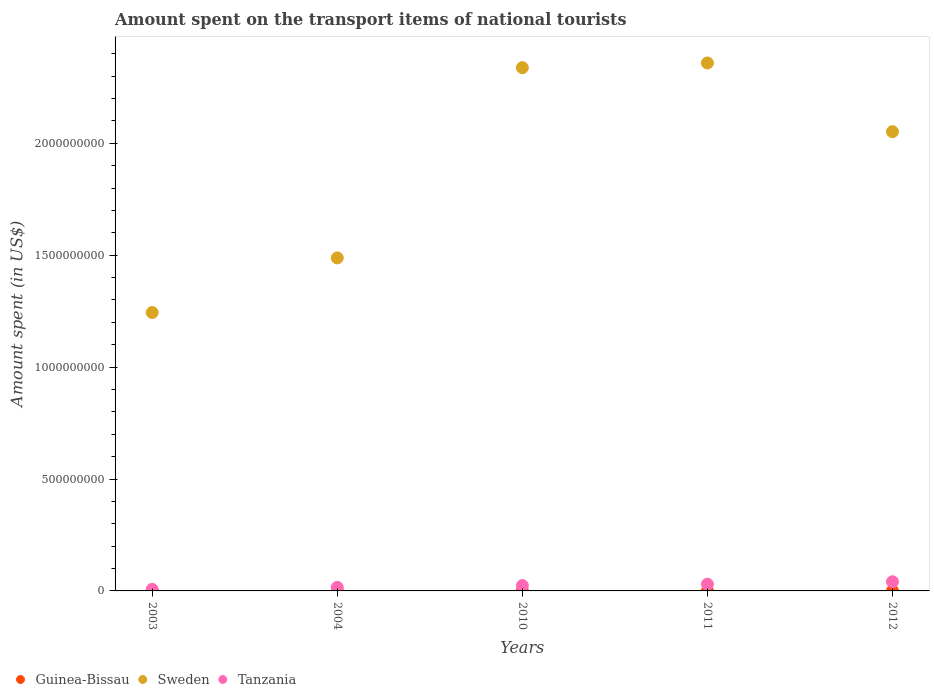Is the number of dotlines equal to the number of legend labels?
Offer a terse response. Yes. What is the amount spent on the transport items of national tourists in Sweden in 2010?
Offer a terse response. 2.34e+09. Across all years, what is the maximum amount spent on the transport items of national tourists in Tanzania?
Your response must be concise. 4.10e+07. In which year was the amount spent on the transport items of national tourists in Sweden maximum?
Offer a very short reply. 2011. What is the total amount spent on the transport items of national tourists in Tanzania in the graph?
Ensure brevity in your answer.  1.18e+08. What is the difference between the amount spent on the transport items of national tourists in Sweden in 2003 and that in 2011?
Make the answer very short. -1.12e+09. What is the difference between the amount spent on the transport items of national tourists in Sweden in 2003 and the amount spent on the transport items of national tourists in Tanzania in 2012?
Ensure brevity in your answer.  1.20e+09. What is the average amount spent on the transport items of national tourists in Sweden per year?
Ensure brevity in your answer.  1.90e+09. In the year 2004, what is the difference between the amount spent on the transport items of national tourists in Tanzania and amount spent on the transport items of national tourists in Sweden?
Provide a short and direct response. -1.47e+09. Is the difference between the amount spent on the transport items of national tourists in Tanzania in 2010 and 2011 greater than the difference between the amount spent on the transport items of national tourists in Sweden in 2010 and 2011?
Make the answer very short. Yes. What is the difference between the highest and the second highest amount spent on the transport items of national tourists in Sweden?
Provide a succinct answer. 2.10e+07. What is the difference between the highest and the lowest amount spent on the transport items of national tourists in Tanzania?
Ensure brevity in your answer.  3.40e+07. In how many years, is the amount spent on the transport items of national tourists in Guinea-Bissau greater than the average amount spent on the transport items of national tourists in Guinea-Bissau taken over all years?
Your answer should be compact. 2. Is the sum of the amount spent on the transport items of national tourists in Tanzania in 2004 and 2010 greater than the maximum amount spent on the transport items of national tourists in Sweden across all years?
Provide a short and direct response. No. Does the amount spent on the transport items of national tourists in Tanzania monotonically increase over the years?
Give a very brief answer. Yes. Is the amount spent on the transport items of national tourists in Tanzania strictly less than the amount spent on the transport items of national tourists in Guinea-Bissau over the years?
Make the answer very short. No. How many years are there in the graph?
Your response must be concise. 5. What is the difference between two consecutive major ticks on the Y-axis?
Give a very brief answer. 5.00e+08. Does the graph contain any zero values?
Offer a very short reply. No. What is the title of the graph?
Your answer should be very brief. Amount spent on the transport items of national tourists. What is the label or title of the Y-axis?
Make the answer very short. Amount spent (in US$). What is the Amount spent (in US$) of Sweden in 2003?
Give a very brief answer. 1.24e+09. What is the Amount spent (in US$) of Guinea-Bissau in 2004?
Your response must be concise. 1.20e+06. What is the Amount spent (in US$) of Sweden in 2004?
Provide a succinct answer. 1.49e+09. What is the Amount spent (in US$) in Tanzania in 2004?
Offer a terse response. 1.60e+07. What is the Amount spent (in US$) of Guinea-Bissau in 2010?
Offer a terse response. 3.00e+05. What is the Amount spent (in US$) of Sweden in 2010?
Provide a short and direct response. 2.34e+09. What is the Amount spent (in US$) in Tanzania in 2010?
Your answer should be compact. 2.40e+07. What is the Amount spent (in US$) of Guinea-Bissau in 2011?
Your answer should be compact. 4.00e+05. What is the Amount spent (in US$) of Sweden in 2011?
Your answer should be very brief. 2.36e+09. What is the Amount spent (in US$) of Tanzania in 2011?
Give a very brief answer. 3.00e+07. What is the Amount spent (in US$) in Guinea-Bissau in 2012?
Provide a succinct answer. 2.00e+05. What is the Amount spent (in US$) in Sweden in 2012?
Keep it short and to the point. 2.05e+09. What is the Amount spent (in US$) of Tanzania in 2012?
Your response must be concise. 4.10e+07. Across all years, what is the maximum Amount spent (in US$) in Guinea-Bissau?
Keep it short and to the point. 1.20e+06. Across all years, what is the maximum Amount spent (in US$) in Sweden?
Offer a very short reply. 2.36e+09. Across all years, what is the maximum Amount spent (in US$) in Tanzania?
Your response must be concise. 4.10e+07. Across all years, what is the minimum Amount spent (in US$) of Sweden?
Offer a terse response. 1.24e+09. What is the total Amount spent (in US$) in Guinea-Bissau in the graph?
Your answer should be very brief. 2.70e+06. What is the total Amount spent (in US$) in Sweden in the graph?
Ensure brevity in your answer.  9.48e+09. What is the total Amount spent (in US$) in Tanzania in the graph?
Your answer should be compact. 1.18e+08. What is the difference between the Amount spent (in US$) of Guinea-Bissau in 2003 and that in 2004?
Provide a succinct answer. -6.00e+05. What is the difference between the Amount spent (in US$) of Sweden in 2003 and that in 2004?
Ensure brevity in your answer.  -2.44e+08. What is the difference between the Amount spent (in US$) of Tanzania in 2003 and that in 2004?
Your answer should be compact. -9.00e+06. What is the difference between the Amount spent (in US$) of Guinea-Bissau in 2003 and that in 2010?
Keep it short and to the point. 3.00e+05. What is the difference between the Amount spent (in US$) of Sweden in 2003 and that in 2010?
Ensure brevity in your answer.  -1.09e+09. What is the difference between the Amount spent (in US$) in Tanzania in 2003 and that in 2010?
Provide a succinct answer. -1.70e+07. What is the difference between the Amount spent (in US$) of Guinea-Bissau in 2003 and that in 2011?
Offer a terse response. 2.00e+05. What is the difference between the Amount spent (in US$) in Sweden in 2003 and that in 2011?
Your answer should be very brief. -1.12e+09. What is the difference between the Amount spent (in US$) of Tanzania in 2003 and that in 2011?
Your answer should be very brief. -2.30e+07. What is the difference between the Amount spent (in US$) of Sweden in 2003 and that in 2012?
Ensure brevity in your answer.  -8.08e+08. What is the difference between the Amount spent (in US$) of Tanzania in 2003 and that in 2012?
Your answer should be compact. -3.40e+07. What is the difference between the Amount spent (in US$) of Sweden in 2004 and that in 2010?
Provide a succinct answer. -8.50e+08. What is the difference between the Amount spent (in US$) of Tanzania in 2004 and that in 2010?
Give a very brief answer. -8.00e+06. What is the difference between the Amount spent (in US$) in Sweden in 2004 and that in 2011?
Keep it short and to the point. -8.71e+08. What is the difference between the Amount spent (in US$) in Tanzania in 2004 and that in 2011?
Ensure brevity in your answer.  -1.40e+07. What is the difference between the Amount spent (in US$) of Guinea-Bissau in 2004 and that in 2012?
Your answer should be very brief. 1.00e+06. What is the difference between the Amount spent (in US$) in Sweden in 2004 and that in 2012?
Provide a succinct answer. -5.64e+08. What is the difference between the Amount spent (in US$) in Tanzania in 2004 and that in 2012?
Provide a short and direct response. -2.50e+07. What is the difference between the Amount spent (in US$) in Sweden in 2010 and that in 2011?
Make the answer very short. -2.10e+07. What is the difference between the Amount spent (in US$) in Tanzania in 2010 and that in 2011?
Your answer should be very brief. -6.00e+06. What is the difference between the Amount spent (in US$) of Sweden in 2010 and that in 2012?
Your answer should be compact. 2.86e+08. What is the difference between the Amount spent (in US$) of Tanzania in 2010 and that in 2012?
Ensure brevity in your answer.  -1.70e+07. What is the difference between the Amount spent (in US$) of Guinea-Bissau in 2011 and that in 2012?
Ensure brevity in your answer.  2.00e+05. What is the difference between the Amount spent (in US$) in Sweden in 2011 and that in 2012?
Make the answer very short. 3.07e+08. What is the difference between the Amount spent (in US$) of Tanzania in 2011 and that in 2012?
Keep it short and to the point. -1.10e+07. What is the difference between the Amount spent (in US$) in Guinea-Bissau in 2003 and the Amount spent (in US$) in Sweden in 2004?
Offer a very short reply. -1.49e+09. What is the difference between the Amount spent (in US$) of Guinea-Bissau in 2003 and the Amount spent (in US$) of Tanzania in 2004?
Your answer should be compact. -1.54e+07. What is the difference between the Amount spent (in US$) in Sweden in 2003 and the Amount spent (in US$) in Tanzania in 2004?
Your answer should be very brief. 1.23e+09. What is the difference between the Amount spent (in US$) of Guinea-Bissau in 2003 and the Amount spent (in US$) of Sweden in 2010?
Offer a terse response. -2.34e+09. What is the difference between the Amount spent (in US$) in Guinea-Bissau in 2003 and the Amount spent (in US$) in Tanzania in 2010?
Your answer should be compact. -2.34e+07. What is the difference between the Amount spent (in US$) in Sweden in 2003 and the Amount spent (in US$) in Tanzania in 2010?
Ensure brevity in your answer.  1.22e+09. What is the difference between the Amount spent (in US$) in Guinea-Bissau in 2003 and the Amount spent (in US$) in Sweden in 2011?
Provide a short and direct response. -2.36e+09. What is the difference between the Amount spent (in US$) of Guinea-Bissau in 2003 and the Amount spent (in US$) of Tanzania in 2011?
Provide a succinct answer. -2.94e+07. What is the difference between the Amount spent (in US$) in Sweden in 2003 and the Amount spent (in US$) in Tanzania in 2011?
Your answer should be compact. 1.21e+09. What is the difference between the Amount spent (in US$) in Guinea-Bissau in 2003 and the Amount spent (in US$) in Sweden in 2012?
Give a very brief answer. -2.05e+09. What is the difference between the Amount spent (in US$) of Guinea-Bissau in 2003 and the Amount spent (in US$) of Tanzania in 2012?
Keep it short and to the point. -4.04e+07. What is the difference between the Amount spent (in US$) of Sweden in 2003 and the Amount spent (in US$) of Tanzania in 2012?
Provide a short and direct response. 1.20e+09. What is the difference between the Amount spent (in US$) of Guinea-Bissau in 2004 and the Amount spent (in US$) of Sweden in 2010?
Give a very brief answer. -2.34e+09. What is the difference between the Amount spent (in US$) in Guinea-Bissau in 2004 and the Amount spent (in US$) in Tanzania in 2010?
Keep it short and to the point. -2.28e+07. What is the difference between the Amount spent (in US$) of Sweden in 2004 and the Amount spent (in US$) of Tanzania in 2010?
Your answer should be very brief. 1.46e+09. What is the difference between the Amount spent (in US$) of Guinea-Bissau in 2004 and the Amount spent (in US$) of Sweden in 2011?
Provide a succinct answer. -2.36e+09. What is the difference between the Amount spent (in US$) in Guinea-Bissau in 2004 and the Amount spent (in US$) in Tanzania in 2011?
Your answer should be very brief. -2.88e+07. What is the difference between the Amount spent (in US$) in Sweden in 2004 and the Amount spent (in US$) in Tanzania in 2011?
Provide a short and direct response. 1.46e+09. What is the difference between the Amount spent (in US$) in Guinea-Bissau in 2004 and the Amount spent (in US$) in Sweden in 2012?
Offer a very short reply. -2.05e+09. What is the difference between the Amount spent (in US$) of Guinea-Bissau in 2004 and the Amount spent (in US$) of Tanzania in 2012?
Keep it short and to the point. -3.98e+07. What is the difference between the Amount spent (in US$) of Sweden in 2004 and the Amount spent (in US$) of Tanzania in 2012?
Offer a terse response. 1.45e+09. What is the difference between the Amount spent (in US$) of Guinea-Bissau in 2010 and the Amount spent (in US$) of Sweden in 2011?
Offer a terse response. -2.36e+09. What is the difference between the Amount spent (in US$) of Guinea-Bissau in 2010 and the Amount spent (in US$) of Tanzania in 2011?
Make the answer very short. -2.97e+07. What is the difference between the Amount spent (in US$) of Sweden in 2010 and the Amount spent (in US$) of Tanzania in 2011?
Provide a short and direct response. 2.31e+09. What is the difference between the Amount spent (in US$) in Guinea-Bissau in 2010 and the Amount spent (in US$) in Sweden in 2012?
Your answer should be compact. -2.05e+09. What is the difference between the Amount spent (in US$) of Guinea-Bissau in 2010 and the Amount spent (in US$) of Tanzania in 2012?
Provide a short and direct response. -4.07e+07. What is the difference between the Amount spent (in US$) in Sweden in 2010 and the Amount spent (in US$) in Tanzania in 2012?
Your response must be concise. 2.30e+09. What is the difference between the Amount spent (in US$) in Guinea-Bissau in 2011 and the Amount spent (in US$) in Sweden in 2012?
Your answer should be very brief. -2.05e+09. What is the difference between the Amount spent (in US$) in Guinea-Bissau in 2011 and the Amount spent (in US$) in Tanzania in 2012?
Ensure brevity in your answer.  -4.06e+07. What is the difference between the Amount spent (in US$) in Sweden in 2011 and the Amount spent (in US$) in Tanzania in 2012?
Your answer should be compact. 2.32e+09. What is the average Amount spent (in US$) in Guinea-Bissau per year?
Your answer should be compact. 5.40e+05. What is the average Amount spent (in US$) in Sweden per year?
Provide a succinct answer. 1.90e+09. What is the average Amount spent (in US$) of Tanzania per year?
Make the answer very short. 2.36e+07. In the year 2003, what is the difference between the Amount spent (in US$) of Guinea-Bissau and Amount spent (in US$) of Sweden?
Your response must be concise. -1.24e+09. In the year 2003, what is the difference between the Amount spent (in US$) of Guinea-Bissau and Amount spent (in US$) of Tanzania?
Your answer should be compact. -6.40e+06. In the year 2003, what is the difference between the Amount spent (in US$) in Sweden and Amount spent (in US$) in Tanzania?
Give a very brief answer. 1.24e+09. In the year 2004, what is the difference between the Amount spent (in US$) in Guinea-Bissau and Amount spent (in US$) in Sweden?
Keep it short and to the point. -1.49e+09. In the year 2004, what is the difference between the Amount spent (in US$) in Guinea-Bissau and Amount spent (in US$) in Tanzania?
Provide a succinct answer. -1.48e+07. In the year 2004, what is the difference between the Amount spent (in US$) of Sweden and Amount spent (in US$) of Tanzania?
Give a very brief answer. 1.47e+09. In the year 2010, what is the difference between the Amount spent (in US$) in Guinea-Bissau and Amount spent (in US$) in Sweden?
Your response must be concise. -2.34e+09. In the year 2010, what is the difference between the Amount spent (in US$) of Guinea-Bissau and Amount spent (in US$) of Tanzania?
Offer a very short reply. -2.37e+07. In the year 2010, what is the difference between the Amount spent (in US$) of Sweden and Amount spent (in US$) of Tanzania?
Make the answer very short. 2.31e+09. In the year 2011, what is the difference between the Amount spent (in US$) of Guinea-Bissau and Amount spent (in US$) of Sweden?
Ensure brevity in your answer.  -2.36e+09. In the year 2011, what is the difference between the Amount spent (in US$) of Guinea-Bissau and Amount spent (in US$) of Tanzania?
Ensure brevity in your answer.  -2.96e+07. In the year 2011, what is the difference between the Amount spent (in US$) in Sweden and Amount spent (in US$) in Tanzania?
Offer a terse response. 2.33e+09. In the year 2012, what is the difference between the Amount spent (in US$) in Guinea-Bissau and Amount spent (in US$) in Sweden?
Provide a succinct answer. -2.05e+09. In the year 2012, what is the difference between the Amount spent (in US$) in Guinea-Bissau and Amount spent (in US$) in Tanzania?
Keep it short and to the point. -4.08e+07. In the year 2012, what is the difference between the Amount spent (in US$) of Sweden and Amount spent (in US$) of Tanzania?
Provide a short and direct response. 2.01e+09. What is the ratio of the Amount spent (in US$) of Guinea-Bissau in 2003 to that in 2004?
Make the answer very short. 0.5. What is the ratio of the Amount spent (in US$) in Sweden in 2003 to that in 2004?
Give a very brief answer. 0.84. What is the ratio of the Amount spent (in US$) in Tanzania in 2003 to that in 2004?
Offer a very short reply. 0.44. What is the ratio of the Amount spent (in US$) of Guinea-Bissau in 2003 to that in 2010?
Make the answer very short. 2. What is the ratio of the Amount spent (in US$) of Sweden in 2003 to that in 2010?
Your answer should be compact. 0.53. What is the ratio of the Amount spent (in US$) of Tanzania in 2003 to that in 2010?
Ensure brevity in your answer.  0.29. What is the ratio of the Amount spent (in US$) in Guinea-Bissau in 2003 to that in 2011?
Keep it short and to the point. 1.5. What is the ratio of the Amount spent (in US$) in Sweden in 2003 to that in 2011?
Give a very brief answer. 0.53. What is the ratio of the Amount spent (in US$) in Tanzania in 2003 to that in 2011?
Give a very brief answer. 0.23. What is the ratio of the Amount spent (in US$) of Sweden in 2003 to that in 2012?
Provide a succinct answer. 0.61. What is the ratio of the Amount spent (in US$) of Tanzania in 2003 to that in 2012?
Your response must be concise. 0.17. What is the ratio of the Amount spent (in US$) in Guinea-Bissau in 2004 to that in 2010?
Ensure brevity in your answer.  4. What is the ratio of the Amount spent (in US$) in Sweden in 2004 to that in 2010?
Your response must be concise. 0.64. What is the ratio of the Amount spent (in US$) of Tanzania in 2004 to that in 2010?
Keep it short and to the point. 0.67. What is the ratio of the Amount spent (in US$) of Guinea-Bissau in 2004 to that in 2011?
Offer a very short reply. 3. What is the ratio of the Amount spent (in US$) in Sweden in 2004 to that in 2011?
Ensure brevity in your answer.  0.63. What is the ratio of the Amount spent (in US$) in Tanzania in 2004 to that in 2011?
Provide a succinct answer. 0.53. What is the ratio of the Amount spent (in US$) of Guinea-Bissau in 2004 to that in 2012?
Make the answer very short. 6. What is the ratio of the Amount spent (in US$) of Sweden in 2004 to that in 2012?
Keep it short and to the point. 0.73. What is the ratio of the Amount spent (in US$) of Tanzania in 2004 to that in 2012?
Your response must be concise. 0.39. What is the ratio of the Amount spent (in US$) of Guinea-Bissau in 2010 to that in 2011?
Your answer should be very brief. 0.75. What is the ratio of the Amount spent (in US$) of Sweden in 2010 to that in 2011?
Your answer should be very brief. 0.99. What is the ratio of the Amount spent (in US$) of Sweden in 2010 to that in 2012?
Keep it short and to the point. 1.14. What is the ratio of the Amount spent (in US$) of Tanzania in 2010 to that in 2012?
Ensure brevity in your answer.  0.59. What is the ratio of the Amount spent (in US$) of Guinea-Bissau in 2011 to that in 2012?
Ensure brevity in your answer.  2. What is the ratio of the Amount spent (in US$) in Sweden in 2011 to that in 2012?
Your answer should be very brief. 1.15. What is the ratio of the Amount spent (in US$) in Tanzania in 2011 to that in 2012?
Keep it short and to the point. 0.73. What is the difference between the highest and the second highest Amount spent (in US$) of Sweden?
Provide a short and direct response. 2.10e+07. What is the difference between the highest and the second highest Amount spent (in US$) in Tanzania?
Offer a terse response. 1.10e+07. What is the difference between the highest and the lowest Amount spent (in US$) in Guinea-Bissau?
Give a very brief answer. 1.00e+06. What is the difference between the highest and the lowest Amount spent (in US$) in Sweden?
Your answer should be very brief. 1.12e+09. What is the difference between the highest and the lowest Amount spent (in US$) of Tanzania?
Your response must be concise. 3.40e+07. 